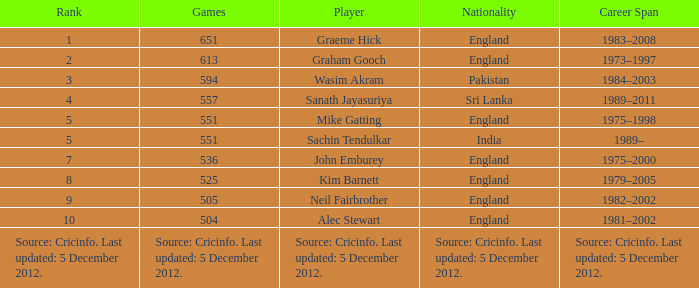What is Graham Gooch's nationality? England. 